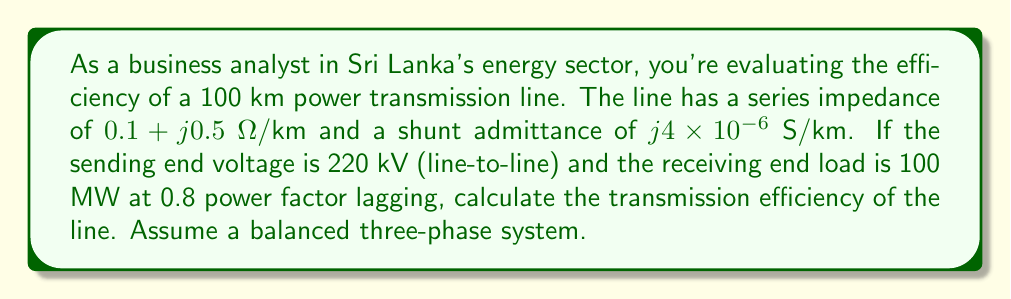Solve this math problem. To solve this problem, we'll follow these steps:

1) Calculate the total series impedance and shunt admittance:
   $$Z = (0.1 + j0.5) \times 100 = 10 + j50 \text{ Ω}$$
   $$Y = j4 \times 10^{-6} \times 100 = j4 \times 10^{-4} \text{ S}$$

2) Calculate the receiving end voltage and current:
   $$V_R = \frac{220\text{ kV}}{\sqrt{3}} = 127\text{ kV (phase voltage)}$$
   $$S_R = 100\text{ MW} + j75\text{ MVAr}$$
   $$I_R = \frac{S_R^*}{3V_R^*} = \frac{100 - j75}{3 \times 127} = 0.262 - j0.197 \text{ kA}$$

3) Use the ABCD parameters of the transmission line:
   $$A = D = 1 + \frac{ZY}{2} = 1 + \frac{(10+j50)(j4\times10^{-4})}{2} = 0.99 + j0.01$$
   $$B = Z = 10 + j50 \text{ Ω}$$
   $$C = Y(1 + \frac{ZY}{4}) \approx j4 \times 10^{-4} \text{ S}$$

4) Calculate the sending end voltage and current:
   $$V_S = AV_R + BI_R = (0.99 + j0.01)(127\angle0°) + (10 + j50)(0.262 - j0.197)$$
   $$V_S = 126.73 + j1.27 + 2.62 + j13.1 - j1.97 + 9.85 = 139.2 + j12.4 = 139.8\angle5.1° \text{ kV}$$
   
   $$I_S = CV_R + DI_R = (j4\times10^{-4})(127\angle0°) + (0.99 + j0.01)(0.262 - j0.197)$$
   $$I_S = j0.0508 + 0.259 - j0.195 = 0.259 - j0.144 = 0.297\angle-29.1° \text{ kA}$$

5) Calculate the sending end power:
   $$S_S = 3V_SI_S^* = 3 \times 139.8\angle5.1° \times 0.297\angle29.1° = 124.5 + j33.8 \text{ MVA}$$

6) Calculate the efficiency:
   $$\text{Efficiency} = \frac{P_R}{P_S} \times 100\% = \frac{100}{124.5} \times 100\% = 80.3\%$$
Answer: The transmission efficiency of the power line is 80.3%. 